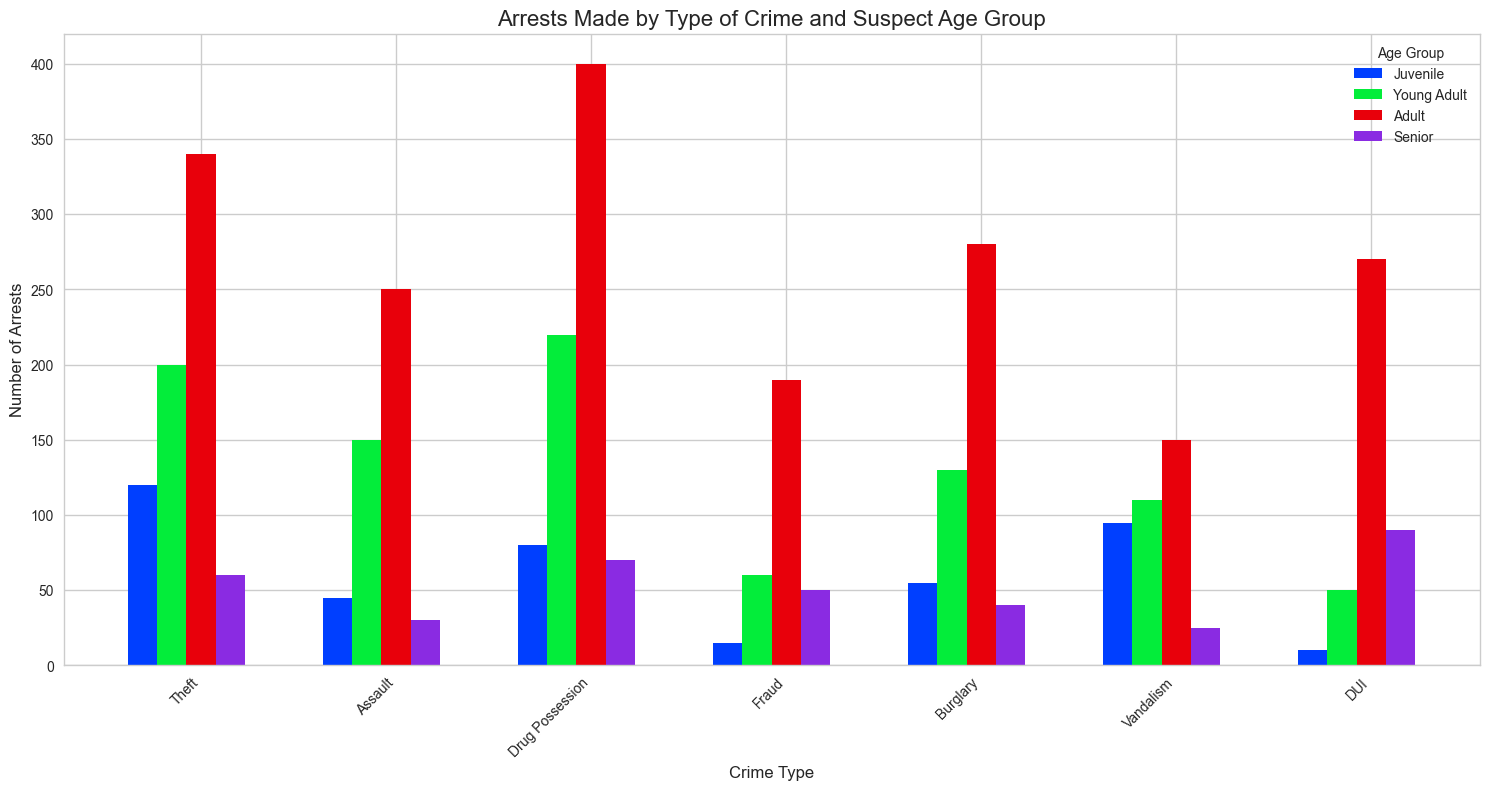How many arrests were made for Drug Possession by Young Adults? Identify the Drug Possession bar for Young Adults, which corresponds to the green bar in the "Drug Possession" category. The height of this bar indicates the number of arrests.
Answer: 220 Which crime type has the highest number of arrests for the Adult age group? Compare the heights of the blue bars for each crime type. The tallest one corresponds to the highest number of arrests for Adults.
Answer: Drug Possession What is the total number of arrests for Juveniles across all crime types? Sum the heights of the purple bars for all crime types: Theft (120) + Assault (45) + Drug Possession (80) + Fraud (15) + Burglary (55) + Vandalism (95) + DUI (10). This leads to 120 + 45 + 80 + 15 + 55 + 95 + 10 = 420.
Answer: 420 What is the difference in the number of arrests between Young Adults and Seniors for Fraud? Look at the heights of the Fraud bars: Young Adults (green) and Seniors (red). Subtract the number of arrests for Seniors (50) from Young Adults (60): 60 - 50.
Answer: 10 Which age group has the smallest number of arrests for DUI? Compare the heights of the bars in the DUI category. The shortest bar represents the age group with the smallest number of arrests.
Answer: Juvenile In the Drug Possession crime category, did Seniors have more arrests than Juveniles? Compare the heights of the Senior and Juvenile bars in the Drug Possession category. The Senior bar (red) is higher than the Juvenile bar (purple).
Answer: Yes What is the total number of arrests for Theft and Vandalism combined for the Adult age group? Add the heights of the blue bars for Theft (340) and Vandalism (150). This leads to 340 + 150 = 490.
Answer: 490 How does the number of arrests for Assault compare between Young Adults and Adults? Compare the heights of the green bar (Young Adults) and the blue bar (Adults) for Assault. The Adult bar (250) is higher than the Young Adult bar (150).
Answer: Adults have more arrests What is the average number of arrests across all age groups for Burglary? Add the number of arrests for all age groups for Burglary and then divide by the number of age groups (4). The calculation is (55+130+280+40)/4 = 505/4 = 126.25.
Answer: 126.25 Which age group has the highest variation in number of arrests across all crime types? This requires looking at the spread between the highest and lowest values for each age group regarding arrests made for each crime type. Juveniles have the highest variation, ranging from a low of 10 (DUI) to a high of 120 (Theft), leading to a variation of 110.
Answer: Juveniles 